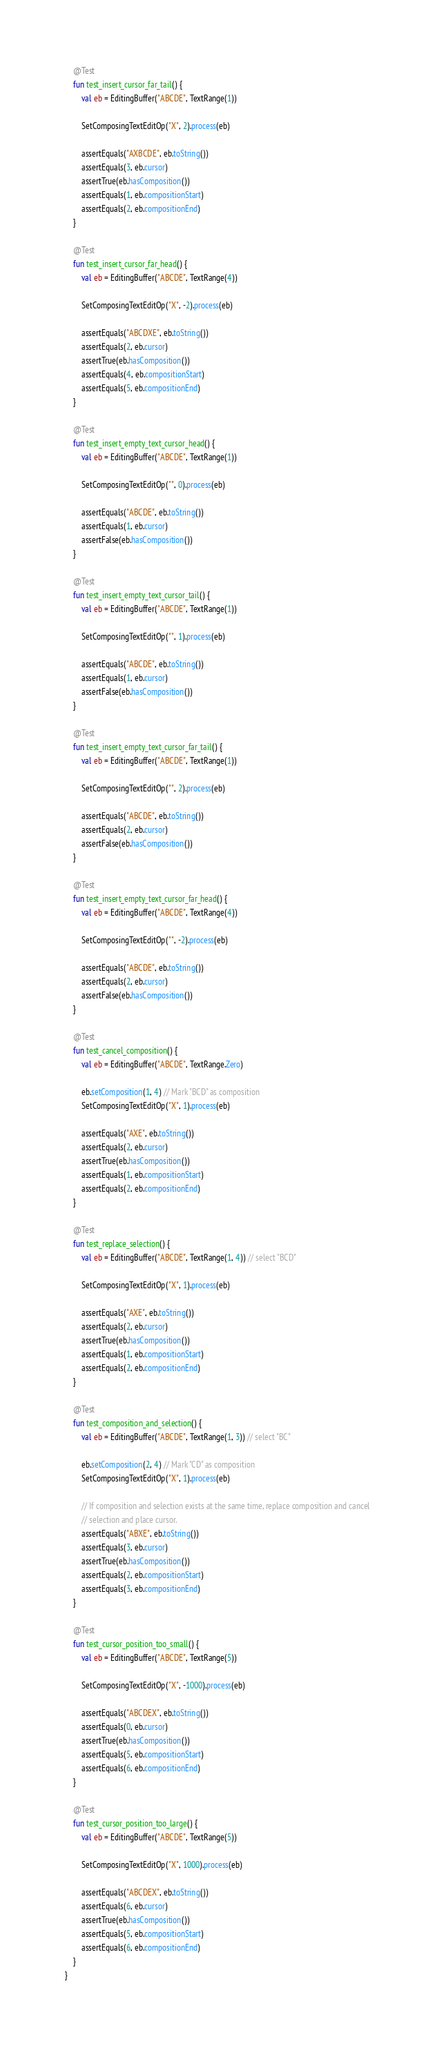Convert code to text. <code><loc_0><loc_0><loc_500><loc_500><_Kotlin_>    @Test
    fun test_insert_cursor_far_tail() {
        val eb = EditingBuffer("ABCDE", TextRange(1))

        SetComposingTextEditOp("X", 2).process(eb)

        assertEquals("AXBCDE", eb.toString())
        assertEquals(3, eb.cursor)
        assertTrue(eb.hasComposition())
        assertEquals(1, eb.compositionStart)
        assertEquals(2, eb.compositionEnd)
    }

    @Test
    fun test_insert_cursor_far_head() {
        val eb = EditingBuffer("ABCDE", TextRange(4))

        SetComposingTextEditOp("X", -2).process(eb)

        assertEquals("ABCDXE", eb.toString())
        assertEquals(2, eb.cursor)
        assertTrue(eb.hasComposition())
        assertEquals(4, eb.compositionStart)
        assertEquals(5, eb.compositionEnd)
    }

    @Test
    fun test_insert_empty_text_cursor_head() {
        val eb = EditingBuffer("ABCDE", TextRange(1))

        SetComposingTextEditOp("", 0).process(eb)

        assertEquals("ABCDE", eb.toString())
        assertEquals(1, eb.cursor)
        assertFalse(eb.hasComposition())
    }

    @Test
    fun test_insert_empty_text_cursor_tail() {
        val eb = EditingBuffer("ABCDE", TextRange(1))

        SetComposingTextEditOp("", 1).process(eb)

        assertEquals("ABCDE", eb.toString())
        assertEquals(1, eb.cursor)
        assertFalse(eb.hasComposition())
    }

    @Test
    fun test_insert_empty_text_cursor_far_tail() {
        val eb = EditingBuffer("ABCDE", TextRange(1))

        SetComposingTextEditOp("", 2).process(eb)

        assertEquals("ABCDE", eb.toString())
        assertEquals(2, eb.cursor)
        assertFalse(eb.hasComposition())
    }

    @Test
    fun test_insert_empty_text_cursor_far_head() {
        val eb = EditingBuffer("ABCDE", TextRange(4))

        SetComposingTextEditOp("", -2).process(eb)

        assertEquals("ABCDE", eb.toString())
        assertEquals(2, eb.cursor)
        assertFalse(eb.hasComposition())
    }

    @Test
    fun test_cancel_composition() {
        val eb = EditingBuffer("ABCDE", TextRange.Zero)

        eb.setComposition(1, 4) // Mark "BCD" as composition
        SetComposingTextEditOp("X", 1).process(eb)

        assertEquals("AXE", eb.toString())
        assertEquals(2, eb.cursor)
        assertTrue(eb.hasComposition())
        assertEquals(1, eb.compositionStart)
        assertEquals(2, eb.compositionEnd)
    }

    @Test
    fun test_replace_selection() {
        val eb = EditingBuffer("ABCDE", TextRange(1, 4)) // select "BCD"

        SetComposingTextEditOp("X", 1).process(eb)

        assertEquals("AXE", eb.toString())
        assertEquals(2, eb.cursor)
        assertTrue(eb.hasComposition())
        assertEquals(1, eb.compositionStart)
        assertEquals(2, eb.compositionEnd)
    }

    @Test
    fun test_composition_and_selection() {
        val eb = EditingBuffer("ABCDE", TextRange(1, 3)) // select "BC"

        eb.setComposition(2, 4) // Mark "CD" as composition
        SetComposingTextEditOp("X", 1).process(eb)

        // If composition and selection exists at the same time, replace composition and cancel
        // selection and place cursor.
        assertEquals("ABXE", eb.toString())
        assertEquals(3, eb.cursor)
        assertTrue(eb.hasComposition())
        assertEquals(2, eb.compositionStart)
        assertEquals(3, eb.compositionEnd)
    }

    @Test
    fun test_cursor_position_too_small() {
        val eb = EditingBuffer("ABCDE", TextRange(5))

        SetComposingTextEditOp("X", -1000).process(eb)

        assertEquals("ABCDEX", eb.toString())
        assertEquals(0, eb.cursor)
        assertTrue(eb.hasComposition())
        assertEquals(5, eb.compositionStart)
        assertEquals(6, eb.compositionEnd)
    }

    @Test
    fun test_cursor_position_too_large() {
        val eb = EditingBuffer("ABCDE", TextRange(5))

        SetComposingTextEditOp("X", 1000).process(eb)

        assertEquals("ABCDEX", eb.toString())
        assertEquals(6, eb.cursor)
        assertTrue(eb.hasComposition())
        assertEquals(5, eb.compositionStart)
        assertEquals(6, eb.compositionEnd)
    }
}</code> 